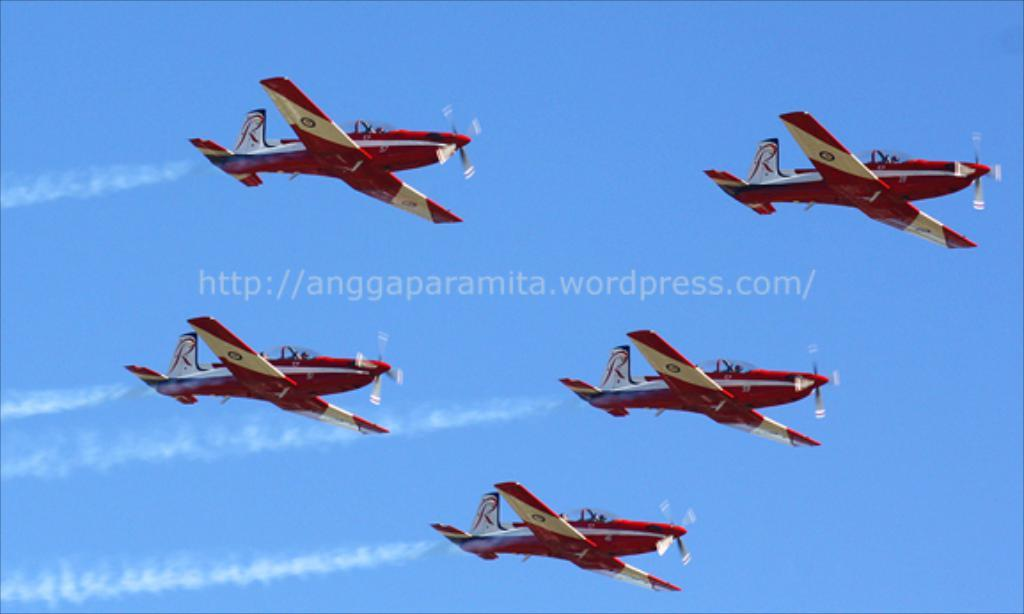How many flying jets can be seen in the image? There are five flying jets in the image. Where are the jets located? The jets are in the sky. What else is visible in the image besides the jets? The sky is visible in the image. Is there any additional information or marking in the image? Yes, there is a watermark in the image. How many legs can be seen on the jets in the image? Jets do not have legs; they are aircraft with wings and engines. --- Facts: 1. There is a person sitting on a bench in the image. 2. The person is reading a book. 3. The bench is in a park. 4. There are trees in the background of the image. 5. The sky is visible in the image. Absurd Topics: fish, bicycle, volcano Conversation: What is the person in the image doing? The person is sitting on a bench and reading a book. Where is the bench located? The bench is in a park. What can be seen in the background of the image? There are trees in the background of the image. What else is visible in the image? The sky is visible in the image. Reasoning: Let's think step by step in order to produce the conversation. We start by identifying the main subject in the image, which is the person sitting on the bench. Then, we describe the person's activity, which is reading a book. Next, we mention the location of the bench, which is in a park. Finally, we acknowledge the presence of trees and the sky as visible elements in the image. Absurd Question/Answer: Can you see any fish swimming in the park in the image? No, there are no fish visible in the image, as it is set in a park and not a body of water. 